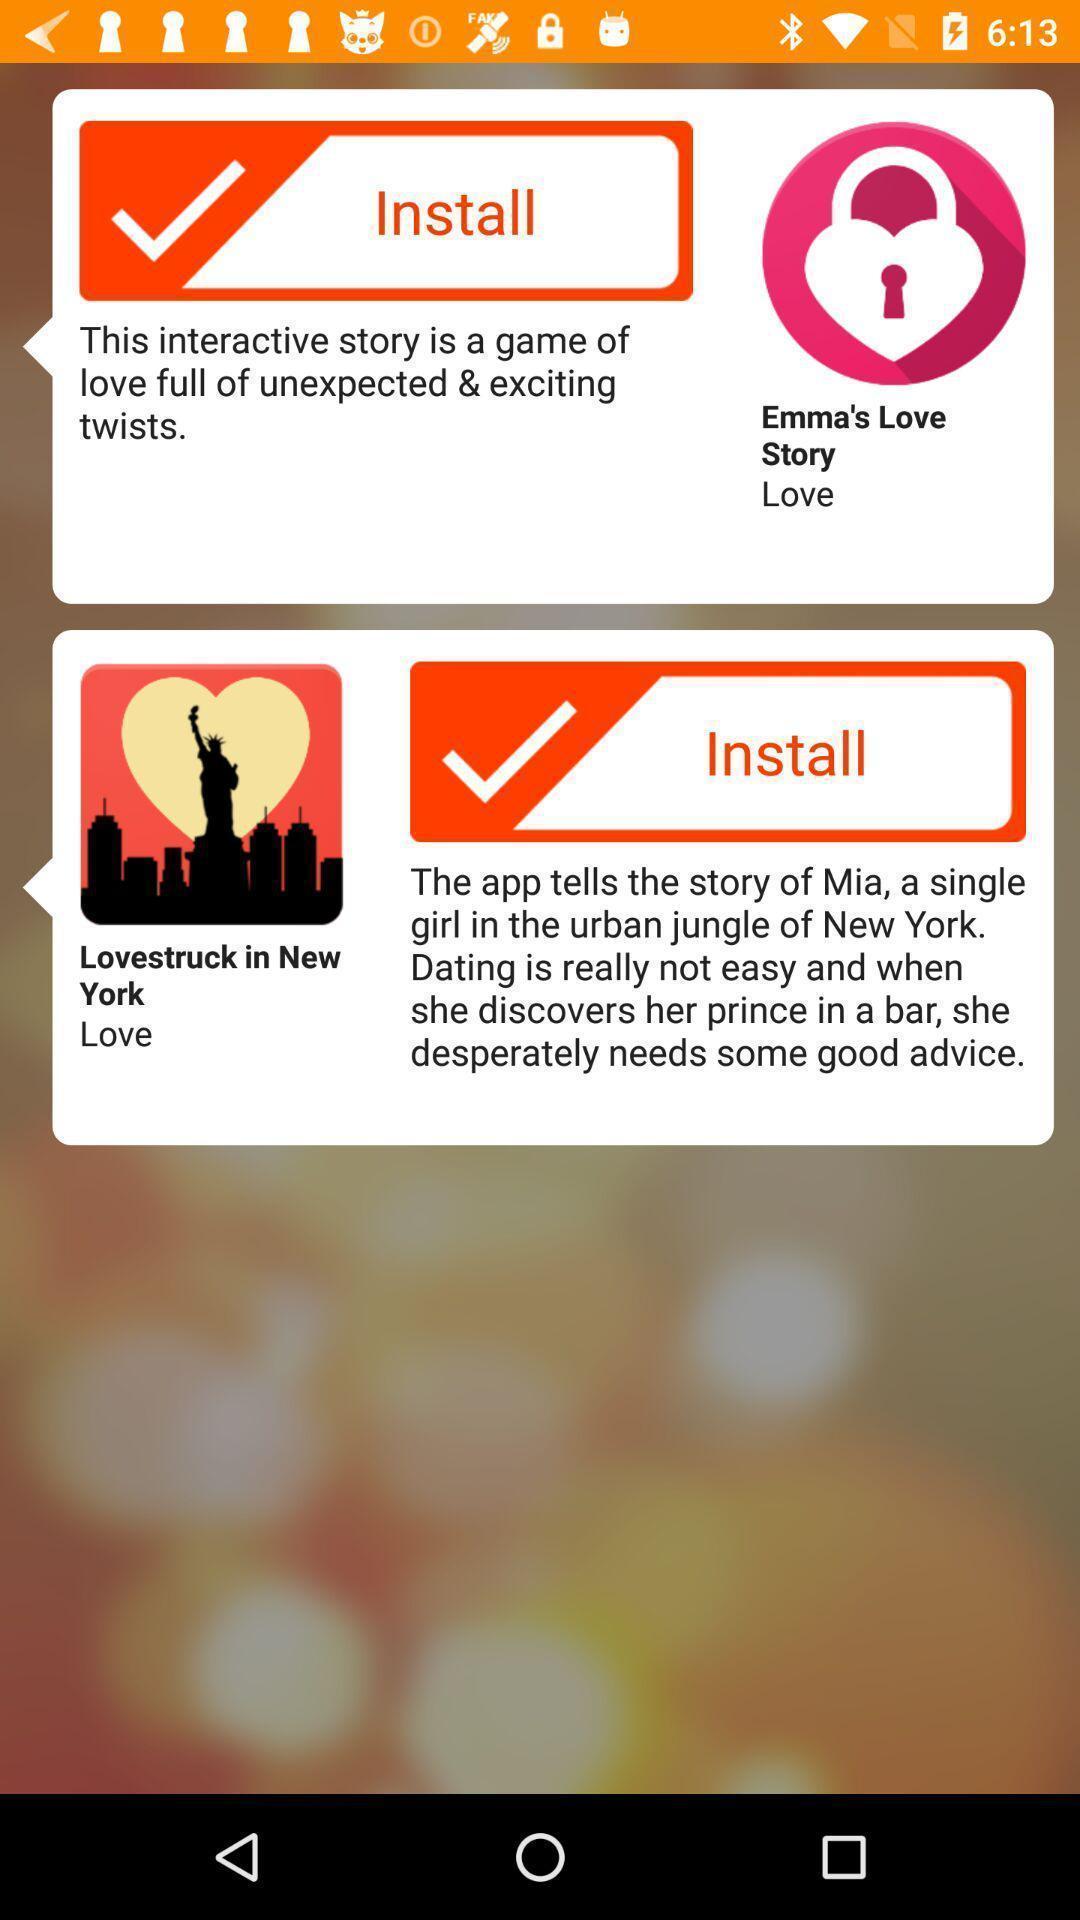Provide a textual representation of this image. Pop-up showing an install message. 